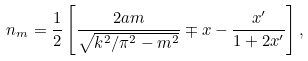Convert formula to latex. <formula><loc_0><loc_0><loc_500><loc_500>n _ { m } = \frac { 1 } { 2 } \left [ \frac { 2 a m } { \sqrt { k ^ { 2 } / \pi ^ { 2 } - m ^ { 2 } } } \mp x - \frac { x ^ { \prime } } { 1 + 2 x ^ { \prime } } \right ] ,</formula> 